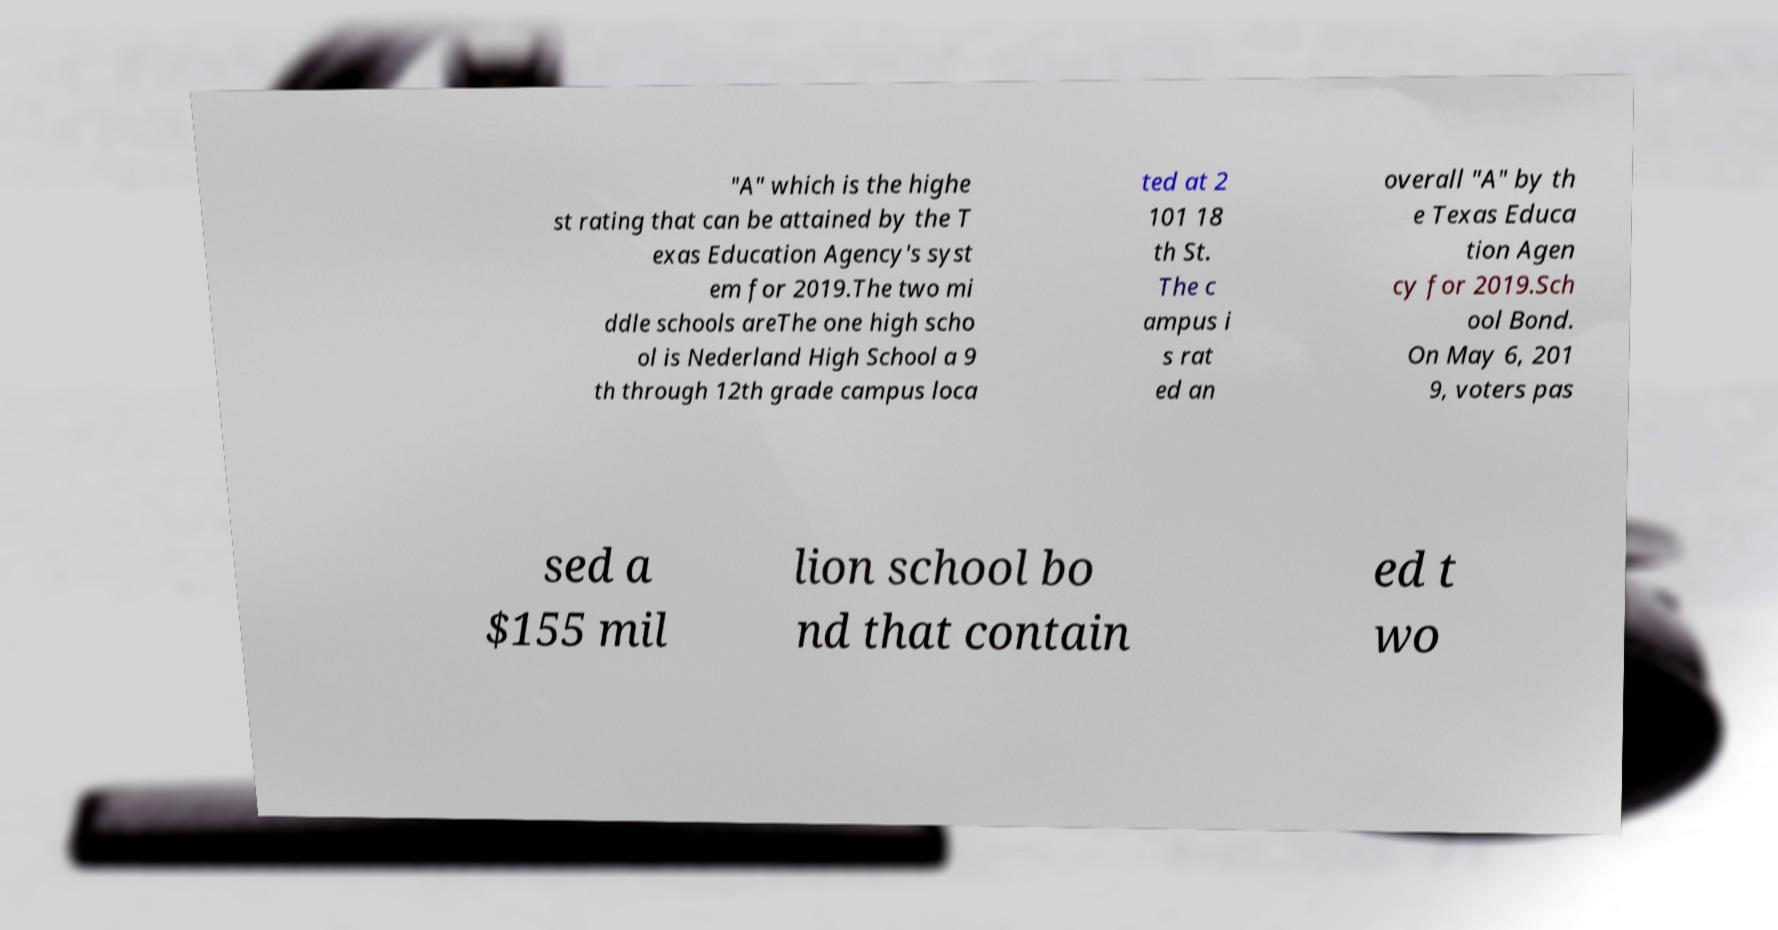There's text embedded in this image that I need extracted. Can you transcribe it verbatim? "A" which is the highe st rating that can be attained by the T exas Education Agency's syst em for 2019.The two mi ddle schools areThe one high scho ol is Nederland High School a 9 th through 12th grade campus loca ted at 2 101 18 th St. The c ampus i s rat ed an overall "A" by th e Texas Educa tion Agen cy for 2019.Sch ool Bond. On May 6, 201 9, voters pas sed a $155 mil lion school bo nd that contain ed t wo 